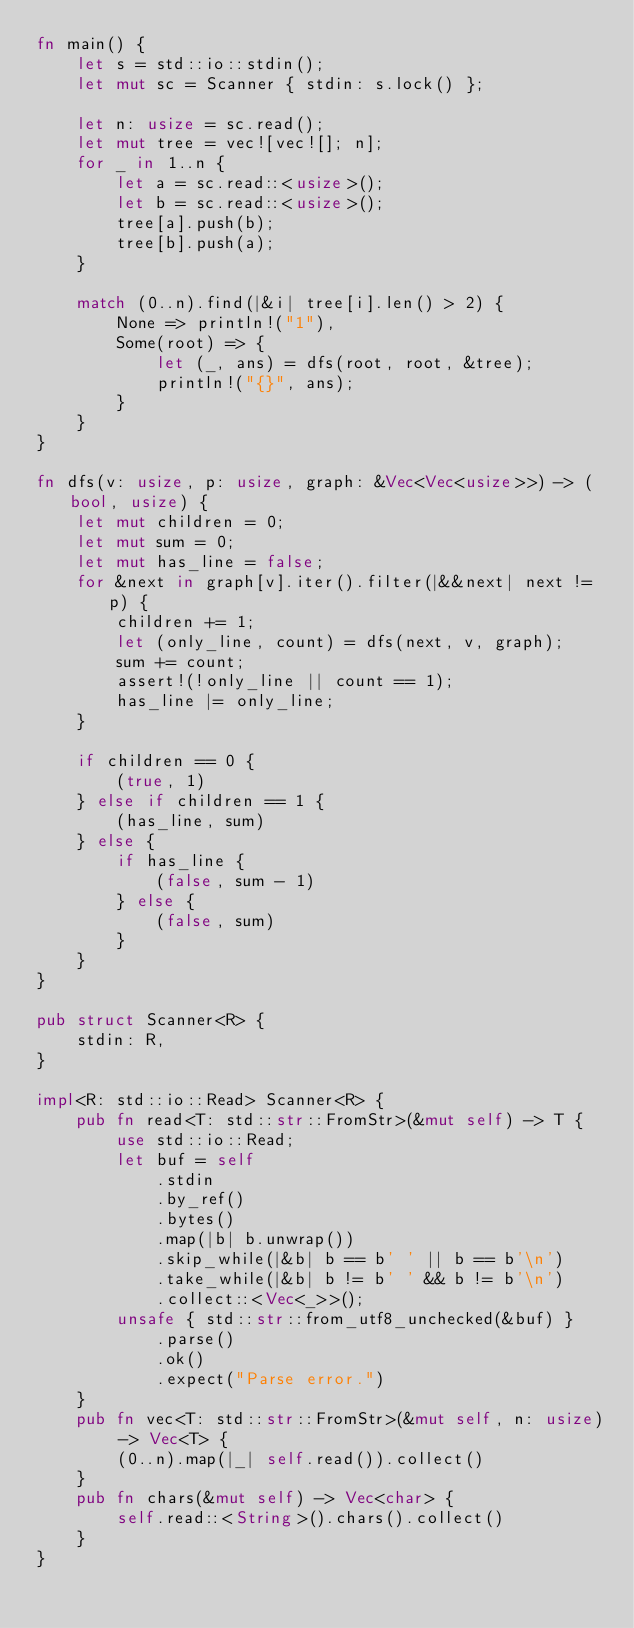<code> <loc_0><loc_0><loc_500><loc_500><_Rust_>fn main() {
    let s = std::io::stdin();
    let mut sc = Scanner { stdin: s.lock() };

    let n: usize = sc.read();
    let mut tree = vec![vec![]; n];
    for _ in 1..n {
        let a = sc.read::<usize>();
        let b = sc.read::<usize>();
        tree[a].push(b);
        tree[b].push(a);
    }

    match (0..n).find(|&i| tree[i].len() > 2) {
        None => println!("1"),
        Some(root) => {
            let (_, ans) = dfs(root, root, &tree);
            println!("{}", ans);
        }
    }
}

fn dfs(v: usize, p: usize, graph: &Vec<Vec<usize>>) -> (bool, usize) {
    let mut children = 0;
    let mut sum = 0;
    let mut has_line = false;
    for &next in graph[v].iter().filter(|&&next| next != p) {
        children += 1;
        let (only_line, count) = dfs(next, v, graph);
        sum += count;
        assert!(!only_line || count == 1);
        has_line |= only_line;
    }

    if children == 0 {
        (true, 1)
    } else if children == 1 {
        (has_line, sum)
    } else {
        if has_line {
            (false, sum - 1)
        } else {
            (false, sum)
        }
    }
}

pub struct Scanner<R> {
    stdin: R,
}

impl<R: std::io::Read> Scanner<R> {
    pub fn read<T: std::str::FromStr>(&mut self) -> T {
        use std::io::Read;
        let buf = self
            .stdin
            .by_ref()
            .bytes()
            .map(|b| b.unwrap())
            .skip_while(|&b| b == b' ' || b == b'\n')
            .take_while(|&b| b != b' ' && b != b'\n')
            .collect::<Vec<_>>();
        unsafe { std::str::from_utf8_unchecked(&buf) }
            .parse()
            .ok()
            .expect("Parse error.")
    }
    pub fn vec<T: std::str::FromStr>(&mut self, n: usize) -> Vec<T> {
        (0..n).map(|_| self.read()).collect()
    }
    pub fn chars(&mut self) -> Vec<char> {
        self.read::<String>().chars().collect()
    }
}
</code> 